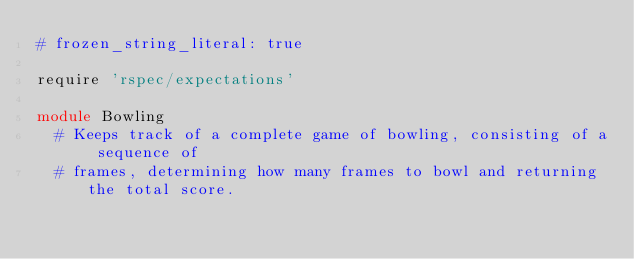Convert code to text. <code><loc_0><loc_0><loc_500><loc_500><_Ruby_># frozen_string_literal: true

require 'rspec/expectations'

module Bowling
  # Keeps track of a complete game of bowling, consisting of a sequence of
  # frames, determining how many frames to bowl and returning the total score.</code> 